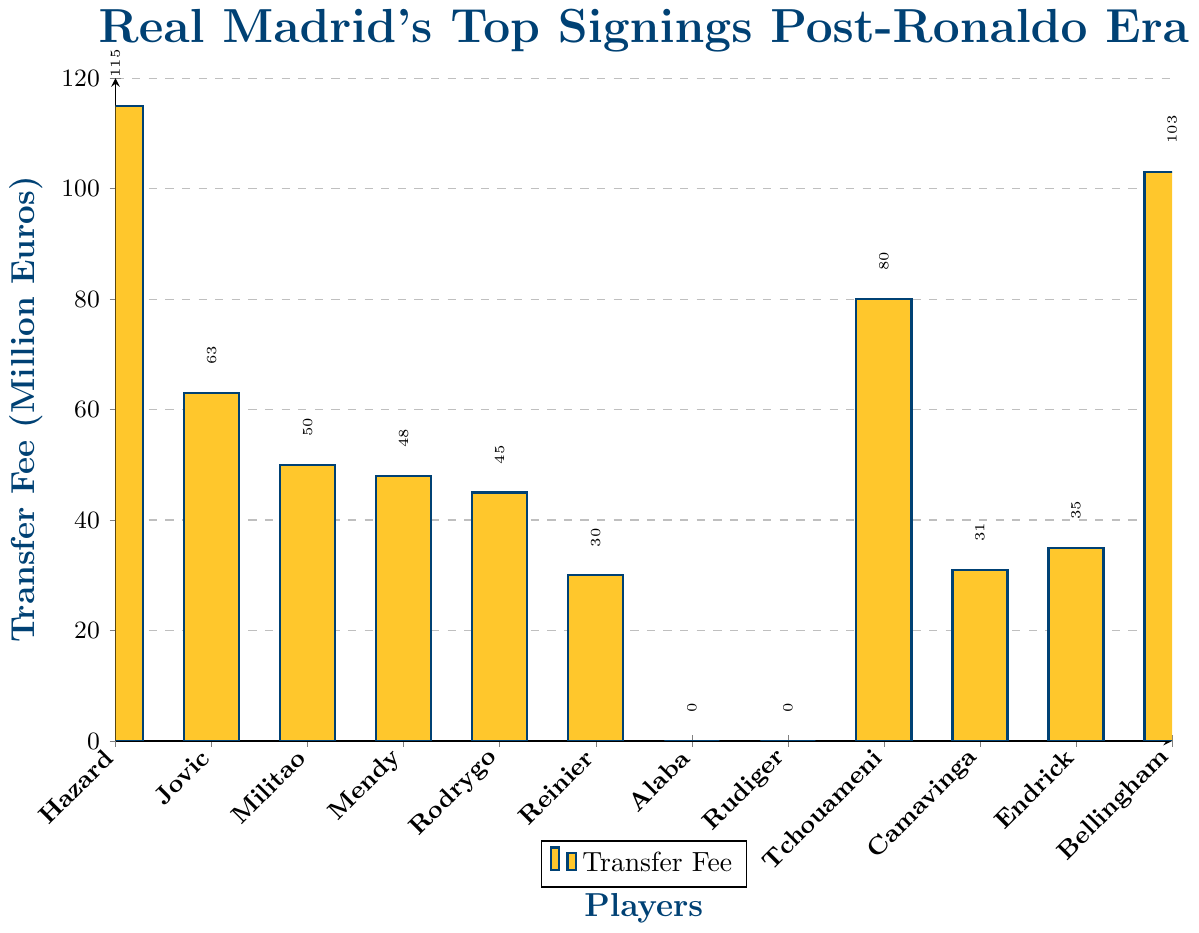Which player has the highest transfer fee in the post-Ronaldo era? By looking at the height of the bars, we see that Eden Hazard has the highest bar, indicating the highest transfer fee.
Answer: Eden Hazard Who are the players that joined Real Madrid for no transfer fee? The bars at zero height represent players who joined for free. These players are David Alaba and Antonio Rudiger.
Answer: David Alaba and Antonio Rudiger What is the difference in transfer fee between the most expensive and the least expensive players? The highest transfer fee is for Eden Hazard at 115 million euros, and the lowest transfer fee for a paid transfer is Reinier at 30 million euros. The difference is 115 - 30 = 85 million euros.
Answer: 85 million euros Which players have a transfer fee of 50 million euros or more? By observing the bars, the players with transfer fees of 50 million euros or more are Eden Hazard, Luka Jovic, Eder Militao, Aurelien Tchouameni, and Jude Bellingham.
Answer: Eden Hazard, Luka Jovic, Eder Militao, Aurelien Tchouameni, Jude Bellingham Average of the transfer fees for Luka Jovic and Ferland Mendy? Luka Jovic's transfer fee is 63 million euros, and Ferland Mendy's is 48 million euros. Adding them gives 63 + 48 = 111 million euros. Dividing by 2, we get 111 / 2 = 55.5 million euros.
Answer: 55.5 million euros Rank the players with positive transfer fees from lowest to highest fee. By observing the height of each bar, the order from lowest to highest is: Reinier (30), Eduardo Camavinga (31), Endrick (35), Rodrygo (45), Ferland Mendy (48), Eder Militao (50), Luka Jovic (63), Aurelien Tchouameni (80), Jude Bellingham (103), Eden Hazard (115).
Answer: Reinier, Eduardo Camavinga, Endrick, Rodrygo, Ferland Mendy, Eder Militao, Luka Jovic, Aurelien Tchouameni, Jude Bellingham, Eden Hazard Name the two players with the closest transfer fees and their fees. By comparing the heights of the bars manually, Ferland Mendy (48) and Rodrygo (45) have the closest transfer fees with a difference of 3 million euros.
Answer: Ferland Mendy (48), Rodrygo (45) Sum of transfer fees for all players excluding the free transfers? Adding up the transfer fees: 115 (Hazard) + 63 (Jovic) + 50 (Militao) + 48 (Mendy) + 45 (Rodrygo) + 30 (Reinier) + 80 (Tchouameni) + 31 (Camavinga) + 35 (Endrick) + 103 (Bellingham) = 600 million euros.
Answer: 600 million euros Which player's transfer fee is nearly double that of Reinier's? Reinier's transfer fee is 30 million euros. Nearly double would be about 60 million euros. Luka Jovic has a transfer fee of 63 million euros, which is closest.
Answer: Luka Jovic 